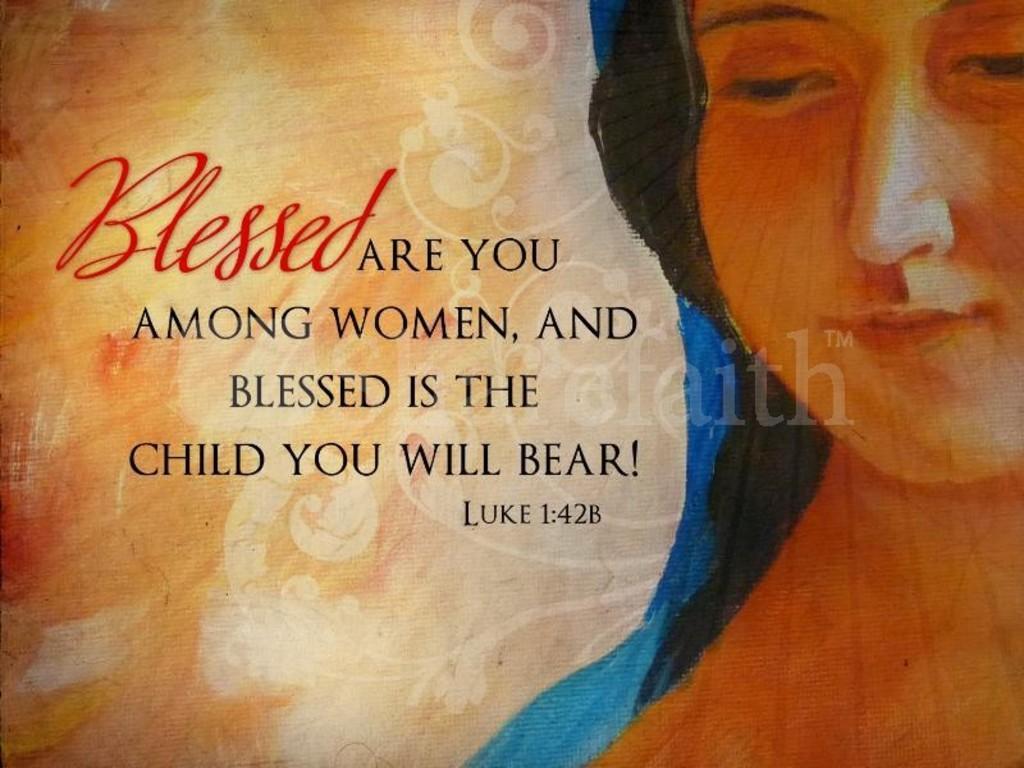In one or two sentences, can you explain what this image depicts? This is a poster having painting of a woman, designs and texts. 